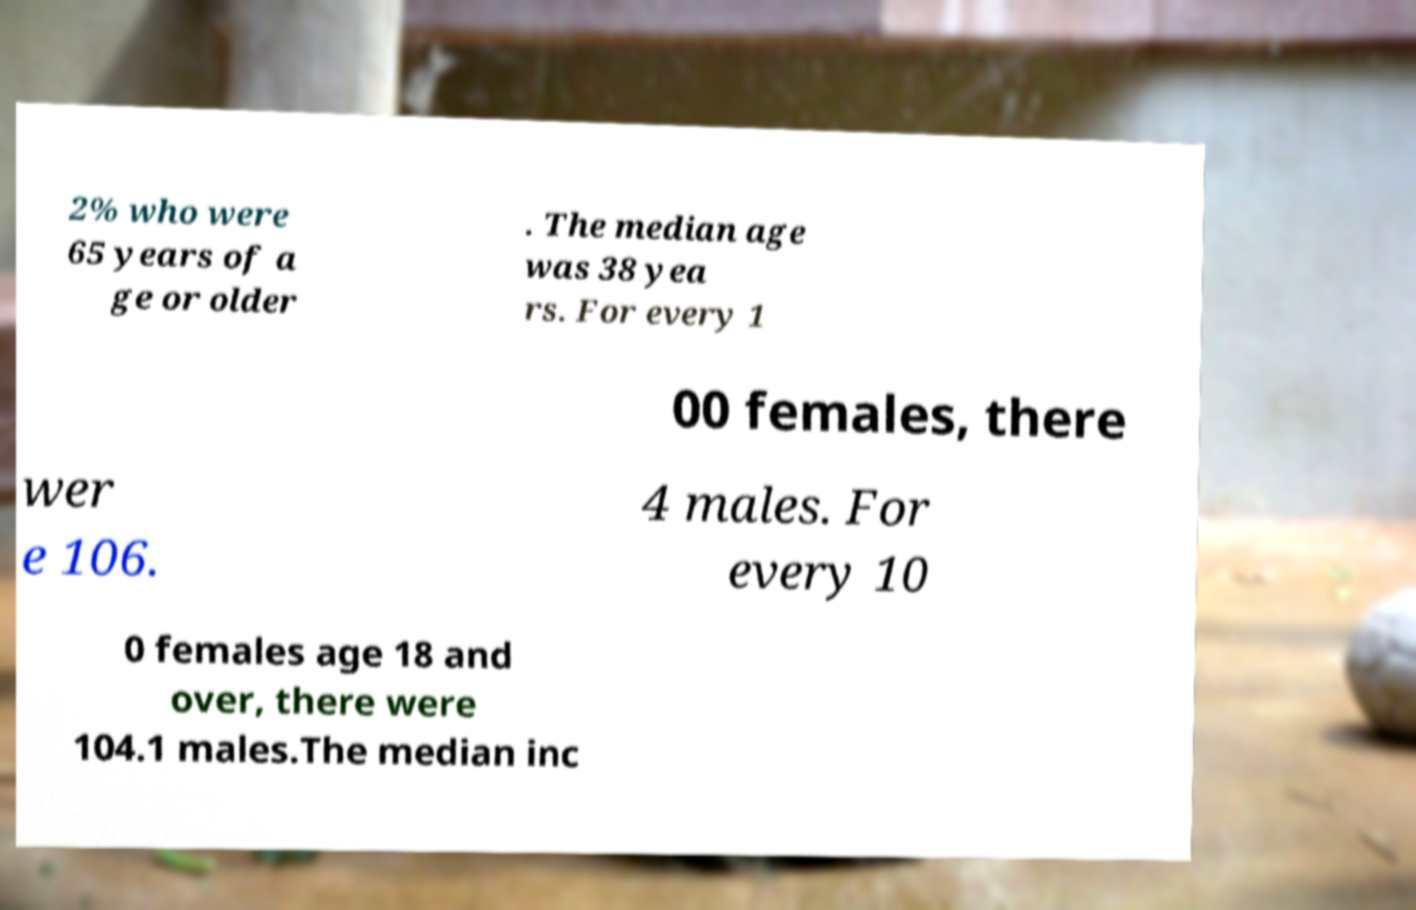Can you read and provide the text displayed in the image?This photo seems to have some interesting text. Can you extract and type it out for me? 2% who were 65 years of a ge or older . The median age was 38 yea rs. For every 1 00 females, there wer e 106. 4 males. For every 10 0 females age 18 and over, there were 104.1 males.The median inc 